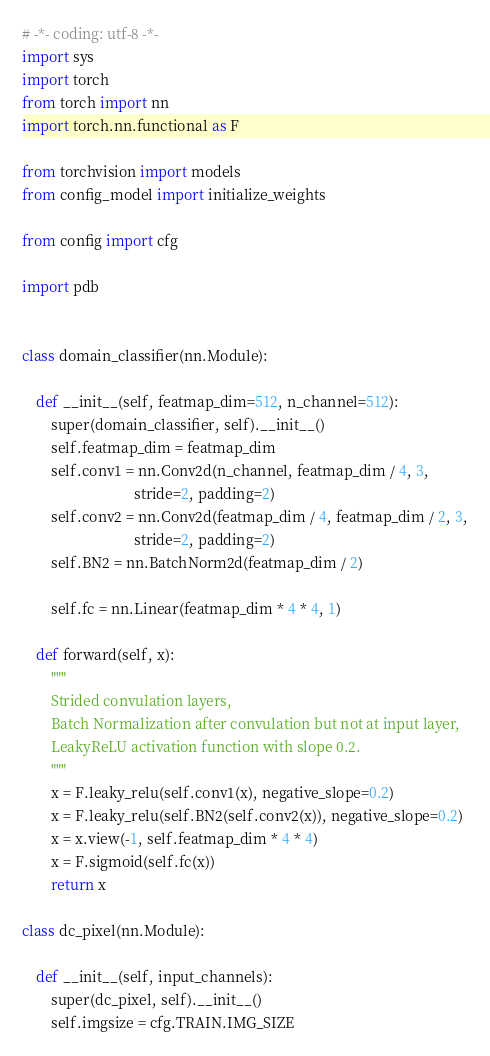Convert code to text. <code><loc_0><loc_0><loc_500><loc_500><_Python_># -*- coding: utf-8 -*-
import sys
import torch
from torch import nn
import torch.nn.functional as F

from torchvision import models
from config_model import initialize_weights

from config import cfg

import pdb


class domain_classifier(nn.Module):

    def __init__(self, featmap_dim=512, n_channel=512):
        super(domain_classifier, self).__init__()
        self.featmap_dim = featmap_dim
        self.conv1 = nn.Conv2d(n_channel, featmap_dim / 4, 3,
                               stride=2, padding=2)
        self.conv2 = nn.Conv2d(featmap_dim / 4, featmap_dim / 2, 3,
                               stride=2, padding=2)
        self.BN2 = nn.BatchNorm2d(featmap_dim / 2)

        self.fc = nn.Linear(featmap_dim * 4 * 4, 1)

    def forward(self, x):
        """
        Strided convulation layers,
        Batch Normalization after convulation but not at input layer,
        LeakyReLU activation function with slope 0.2.
        """
        x = F.leaky_relu(self.conv1(x), negative_slope=0.2)
        x = F.leaky_relu(self.BN2(self.conv2(x)), negative_slope=0.2)
        x = x.view(-1, self.featmap_dim * 4 * 4)
        x = F.sigmoid(self.fc(x))
        return x

class dc_pixel(nn.Module):

    def __init__(self, input_channels):
        super(dc_pixel, self).__init__()
        self.imgsize = cfg.TRAIN.IMG_SIZE
</code> 